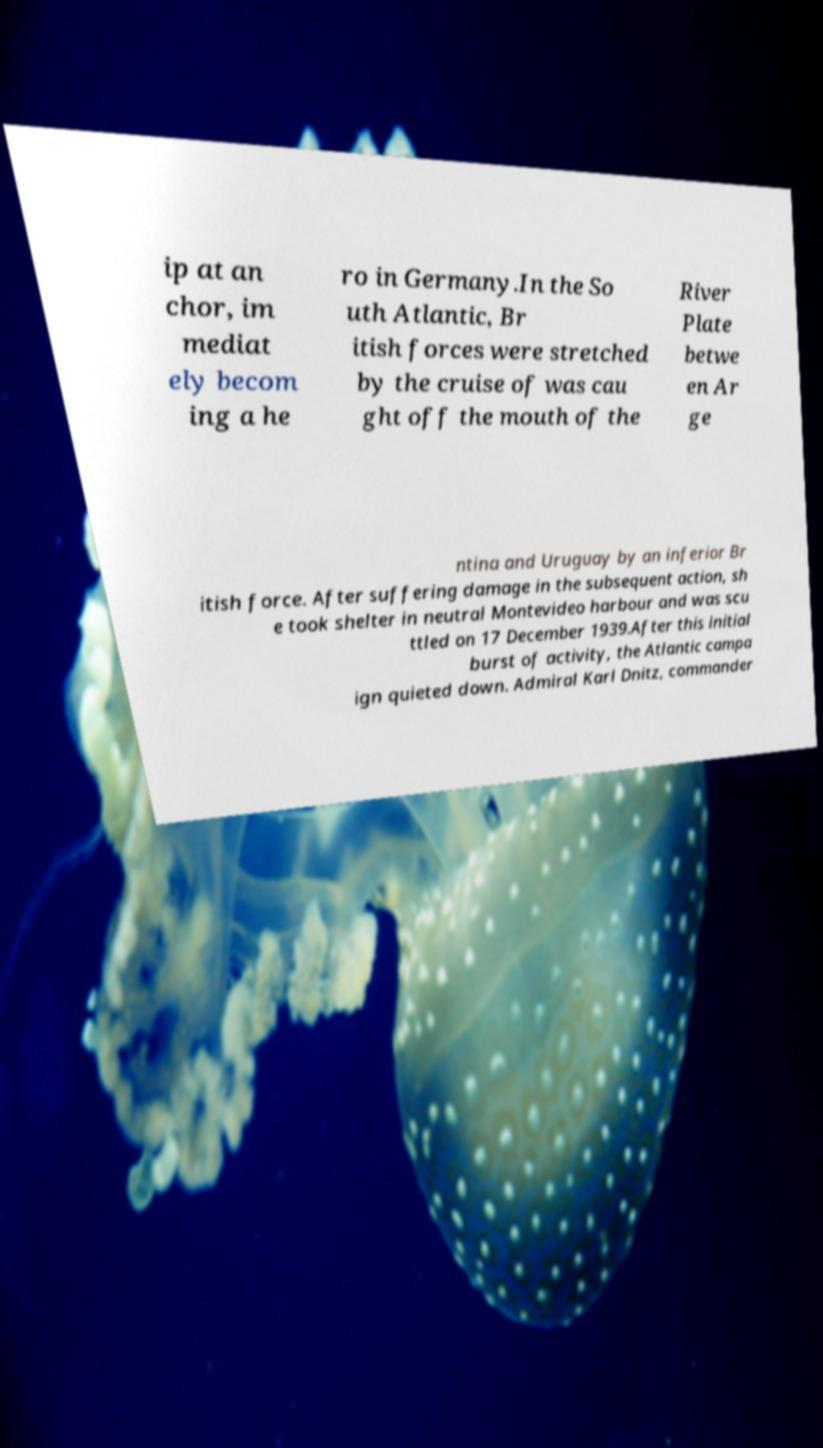There's text embedded in this image that I need extracted. Can you transcribe it verbatim? ip at an chor, im mediat ely becom ing a he ro in Germany.In the So uth Atlantic, Br itish forces were stretched by the cruise of was cau ght off the mouth of the River Plate betwe en Ar ge ntina and Uruguay by an inferior Br itish force. After suffering damage in the subsequent action, sh e took shelter in neutral Montevideo harbour and was scu ttled on 17 December 1939.After this initial burst of activity, the Atlantic campa ign quieted down. Admiral Karl Dnitz, commander 